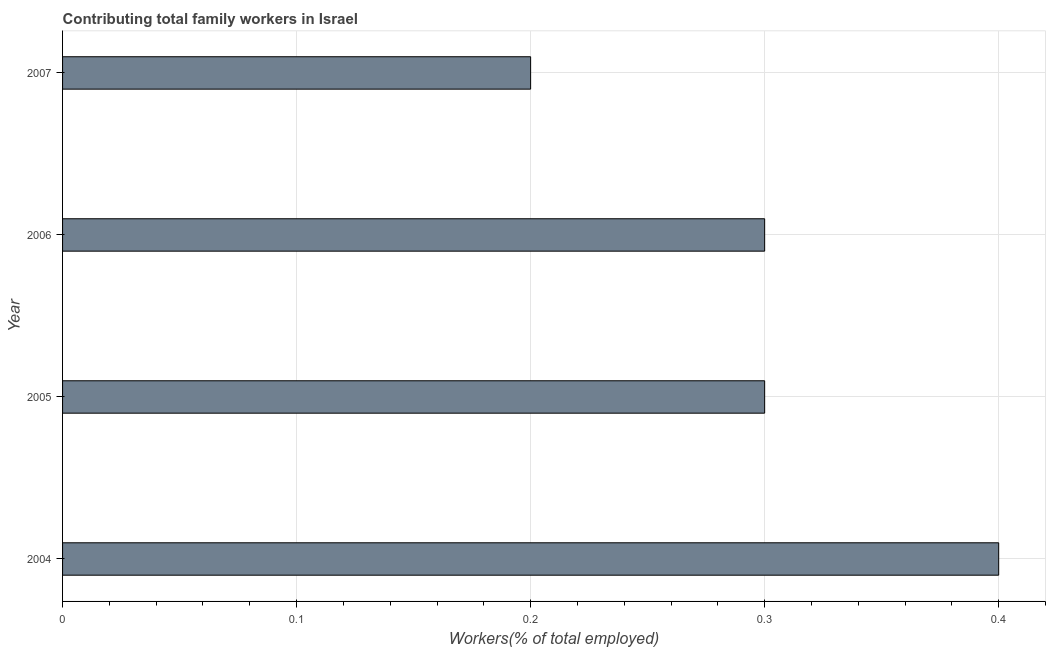Does the graph contain any zero values?
Make the answer very short. No. What is the title of the graph?
Your response must be concise. Contributing total family workers in Israel. What is the label or title of the X-axis?
Give a very brief answer. Workers(% of total employed). What is the label or title of the Y-axis?
Make the answer very short. Year. What is the contributing family workers in 2006?
Your response must be concise. 0.3. Across all years, what is the maximum contributing family workers?
Provide a short and direct response. 0.4. Across all years, what is the minimum contributing family workers?
Give a very brief answer. 0.2. In which year was the contributing family workers maximum?
Keep it short and to the point. 2004. In which year was the contributing family workers minimum?
Make the answer very short. 2007. What is the sum of the contributing family workers?
Your answer should be very brief. 1.2. What is the average contributing family workers per year?
Provide a succinct answer. 0.3. What is the median contributing family workers?
Provide a short and direct response. 0.3. In how many years, is the contributing family workers greater than 0.04 %?
Your answer should be very brief. 4. What is the ratio of the contributing family workers in 2004 to that in 2007?
Keep it short and to the point. 2. Is the contributing family workers in 2004 less than that in 2006?
Ensure brevity in your answer.  No. Is the sum of the contributing family workers in 2005 and 2007 greater than the maximum contributing family workers across all years?
Give a very brief answer. Yes. In how many years, is the contributing family workers greater than the average contributing family workers taken over all years?
Keep it short and to the point. 3. How many bars are there?
Provide a succinct answer. 4. Are all the bars in the graph horizontal?
Your answer should be very brief. Yes. What is the difference between two consecutive major ticks on the X-axis?
Ensure brevity in your answer.  0.1. What is the Workers(% of total employed) of 2004?
Ensure brevity in your answer.  0.4. What is the Workers(% of total employed) of 2005?
Your answer should be compact. 0.3. What is the Workers(% of total employed) of 2006?
Ensure brevity in your answer.  0.3. What is the Workers(% of total employed) in 2007?
Offer a very short reply. 0.2. What is the difference between the Workers(% of total employed) in 2004 and 2005?
Ensure brevity in your answer.  0.1. What is the difference between the Workers(% of total employed) in 2004 and 2007?
Give a very brief answer. 0.2. What is the difference between the Workers(% of total employed) in 2006 and 2007?
Make the answer very short. 0.1. What is the ratio of the Workers(% of total employed) in 2004 to that in 2005?
Your answer should be very brief. 1.33. What is the ratio of the Workers(% of total employed) in 2004 to that in 2006?
Ensure brevity in your answer.  1.33. What is the ratio of the Workers(% of total employed) in 2004 to that in 2007?
Offer a terse response. 2. What is the ratio of the Workers(% of total employed) in 2005 to that in 2006?
Your answer should be very brief. 1. What is the ratio of the Workers(% of total employed) in 2006 to that in 2007?
Offer a very short reply. 1.5. 